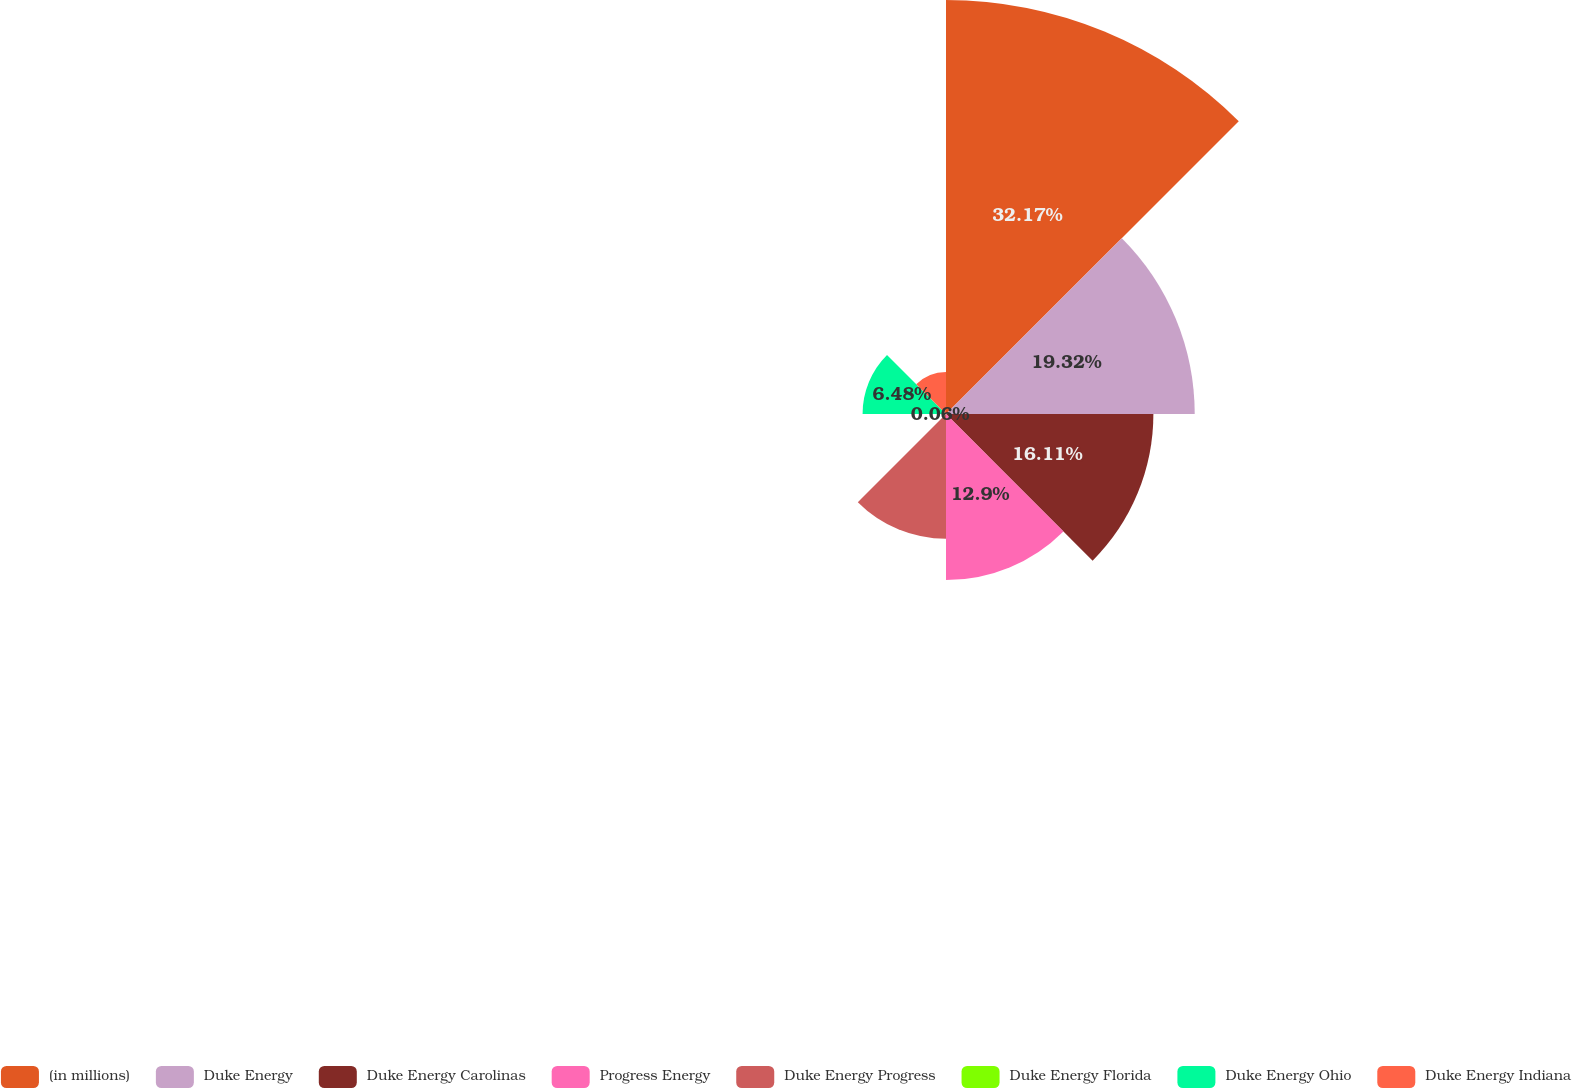<chart> <loc_0><loc_0><loc_500><loc_500><pie_chart><fcel>(in millions)<fcel>Duke Energy<fcel>Duke Energy Carolinas<fcel>Progress Energy<fcel>Duke Energy Progress<fcel>Duke Energy Florida<fcel>Duke Energy Ohio<fcel>Duke Energy Indiana<nl><fcel>32.16%<fcel>19.32%<fcel>16.11%<fcel>12.9%<fcel>9.69%<fcel>0.06%<fcel>6.48%<fcel>3.27%<nl></chart> 